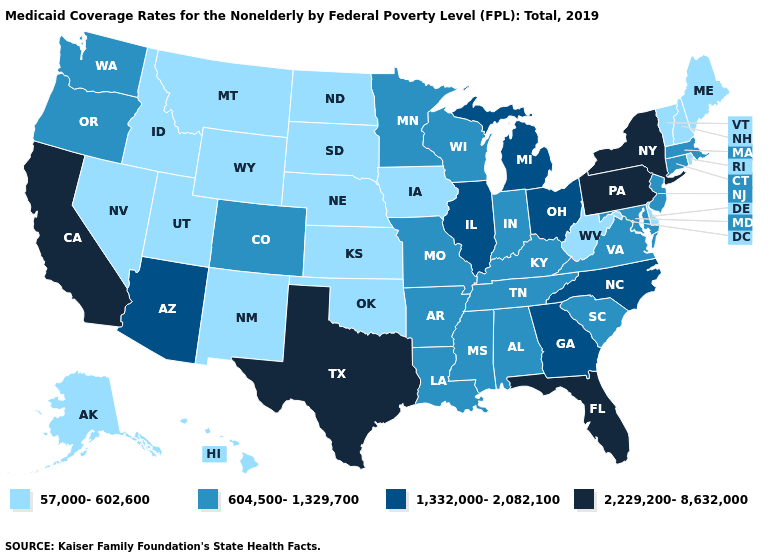Among the states that border Alabama , which have the highest value?
Keep it brief. Florida. What is the highest value in the Northeast ?
Be succinct. 2,229,200-8,632,000. Does New York have the highest value in the Northeast?
Concise answer only. Yes. Does Rhode Island have the lowest value in the Northeast?
Keep it brief. Yes. What is the value of Delaware?
Write a very short answer. 57,000-602,600. What is the value of Kansas?
Write a very short answer. 57,000-602,600. What is the value of Mississippi?
Keep it brief. 604,500-1,329,700. What is the value of Alaska?
Answer briefly. 57,000-602,600. What is the value of Texas?
Give a very brief answer. 2,229,200-8,632,000. Does Maine have the lowest value in the USA?
Keep it brief. Yes. Is the legend a continuous bar?
Write a very short answer. No. Among the states that border Vermont , which have the highest value?
Concise answer only. New York. Does West Virginia have the same value as South Carolina?
Be succinct. No. Does New Mexico have the highest value in the USA?
Answer briefly. No. Name the states that have a value in the range 604,500-1,329,700?
Concise answer only. Alabama, Arkansas, Colorado, Connecticut, Indiana, Kentucky, Louisiana, Maryland, Massachusetts, Minnesota, Mississippi, Missouri, New Jersey, Oregon, South Carolina, Tennessee, Virginia, Washington, Wisconsin. 